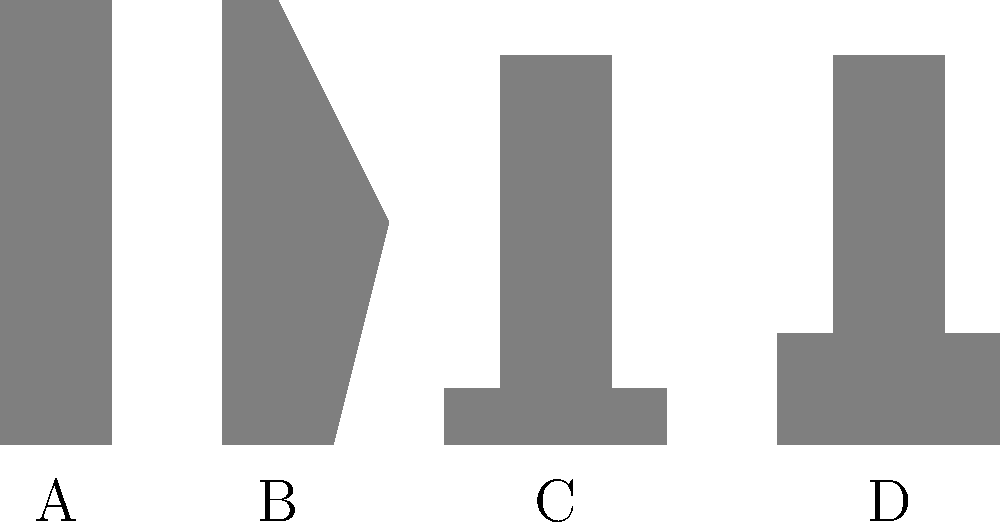Identify the 19th-century Australian frontier tool or weapon represented by silhouette B in the image above. To identify the 19th-century Australian frontier tool or weapon represented by silhouette B, let's analyze each silhouette:

1. Silhouette A: This appears to be a rectangular shape, likely representing a book or ledger.

2. Silhouette B: This silhouette has a distinctive curved shape with a wider base and a narrower top. It closely resembles the shape of a boomerang, a traditional Aboriginal Australian throwing weapon that was also encountered by frontier settlers.

3. Silhouette C: This shape looks like a typical axe or hatchet, with a long handle and a wedge-shaped head.

4. Silhouette D: This silhouette represents a hammer or mallet, with a long handle and a rectangular head.

Given the distinctive curved shape of silhouette B and its association with Australian frontier history, the most likely identification is a boomerang.
Answer: Boomerang 